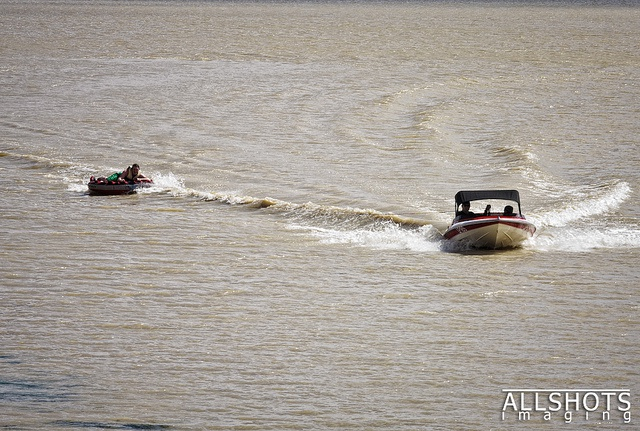Describe the objects in this image and their specific colors. I can see boat in gray, black, lightgray, and darkgray tones, boat in gray, black, darkgray, and maroon tones, people in gray, black, maroon, darkgray, and white tones, people in gray, black, darkgray, and white tones, and people in gray, black, darkgray, and lightgray tones in this image. 